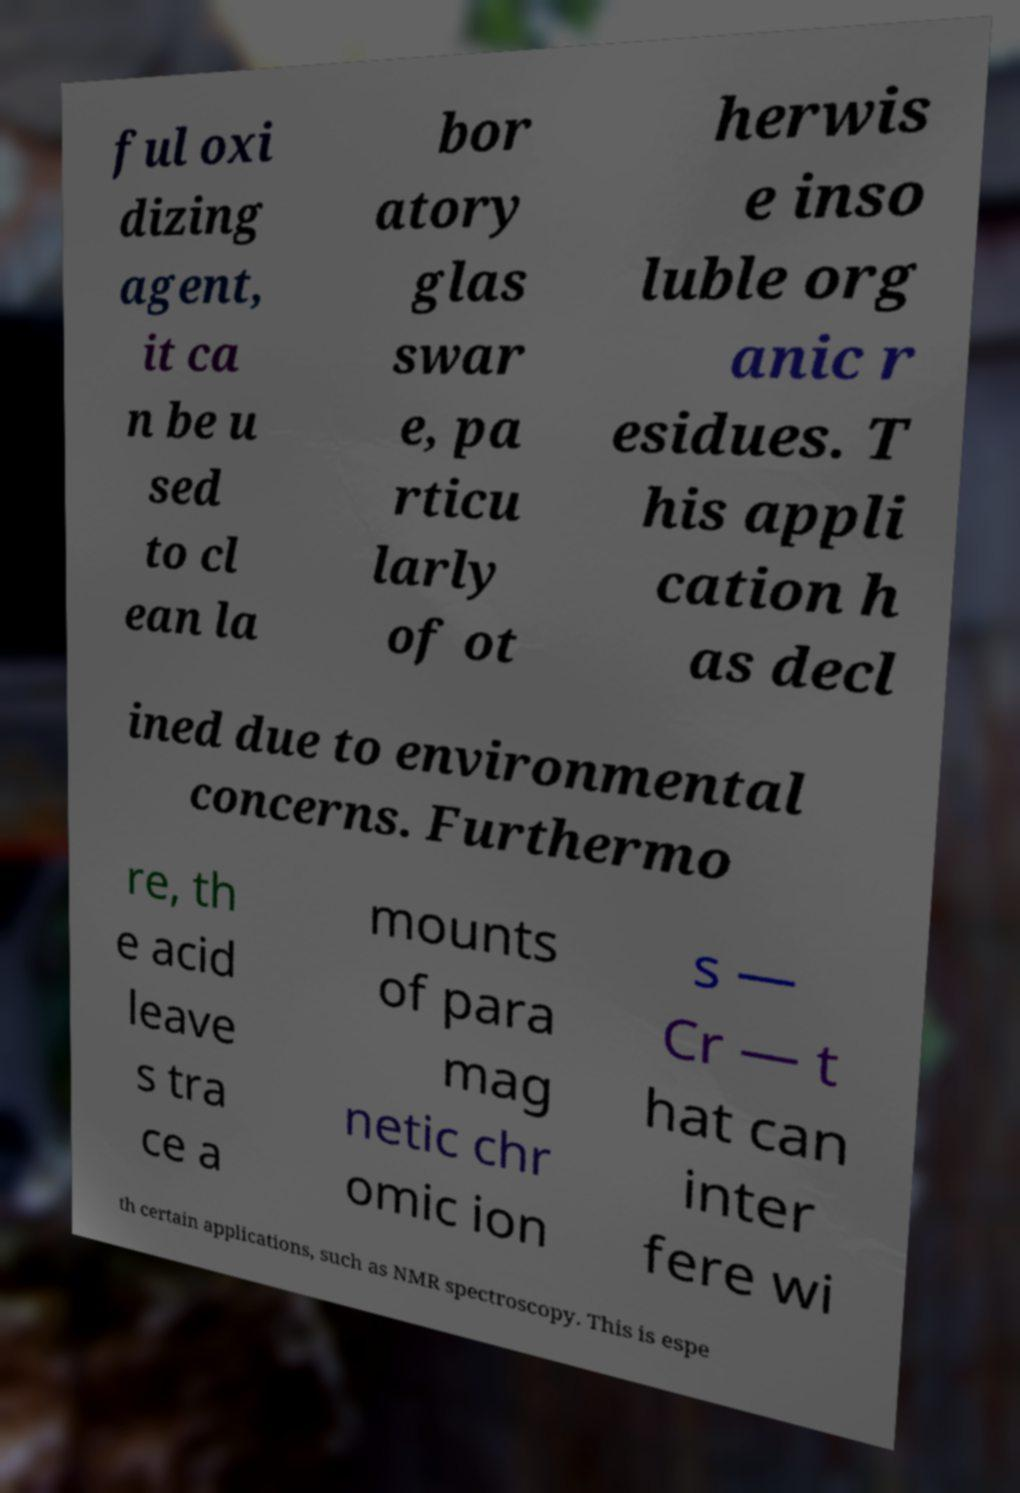There's text embedded in this image that I need extracted. Can you transcribe it verbatim? ful oxi dizing agent, it ca n be u sed to cl ean la bor atory glas swar e, pa rticu larly of ot herwis e inso luble org anic r esidues. T his appli cation h as decl ined due to environmental concerns. Furthermo re, th e acid leave s tra ce a mounts of para mag netic chr omic ion s — Cr — t hat can inter fere wi th certain applications, such as NMR spectroscopy. This is espe 